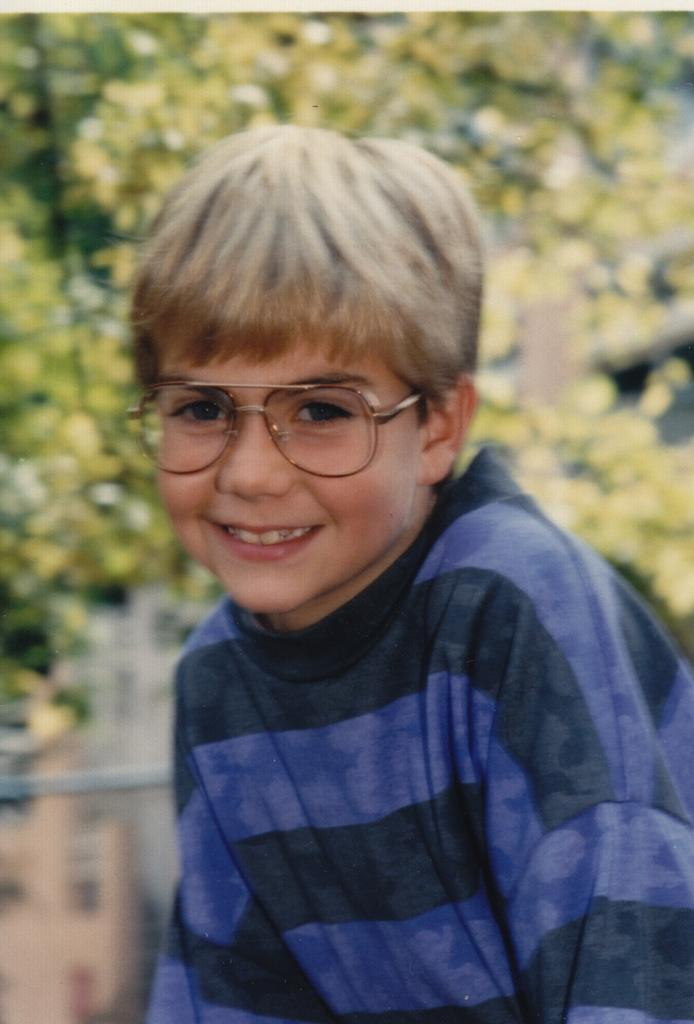Who is in the image? There is a person in the image. What is the person wearing? The person is wearing a blue dress. What expression does the person have? The person is smiling. What can be seen in the background of the image? There are trees visible in the background of the image. How would you describe the background of the image? The background appears blurred. What flavor of toothpaste is the person using in the image? There is no toothpaste present in the image, and therefore no such activity can be observed. 